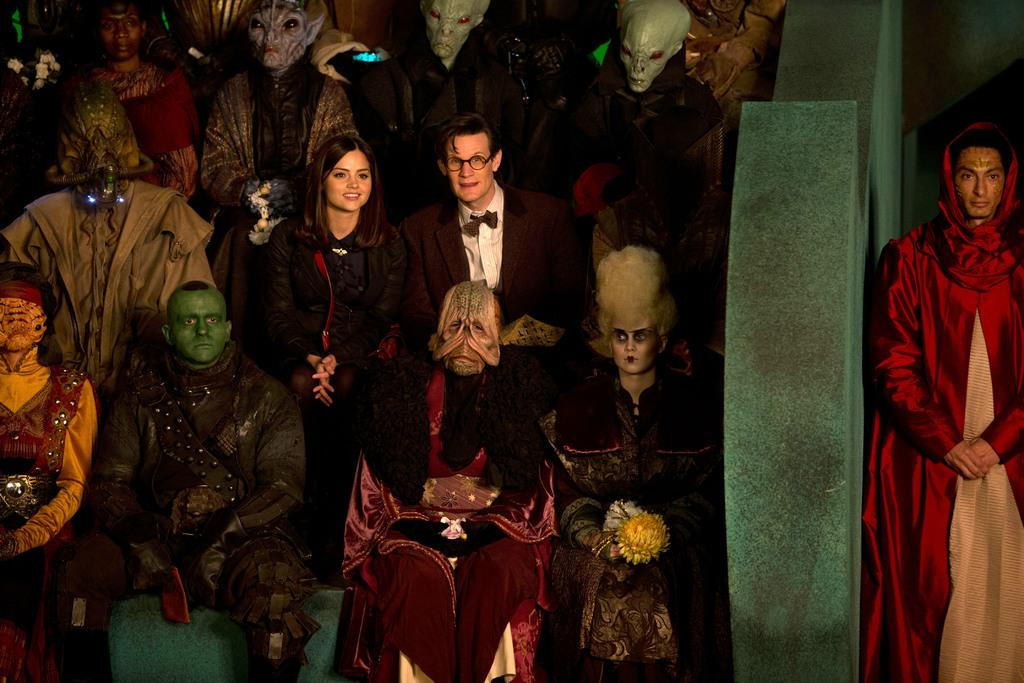What are the people in the image doing? The people in the image are sitting on the floor. What are the people wearing? The people are wearing costumes. What can be seen on the faces of the people? The people have masks on their faces. What type of marble is being used for the volleyball game in the image? There is no marble or volleyball game present in the image. 